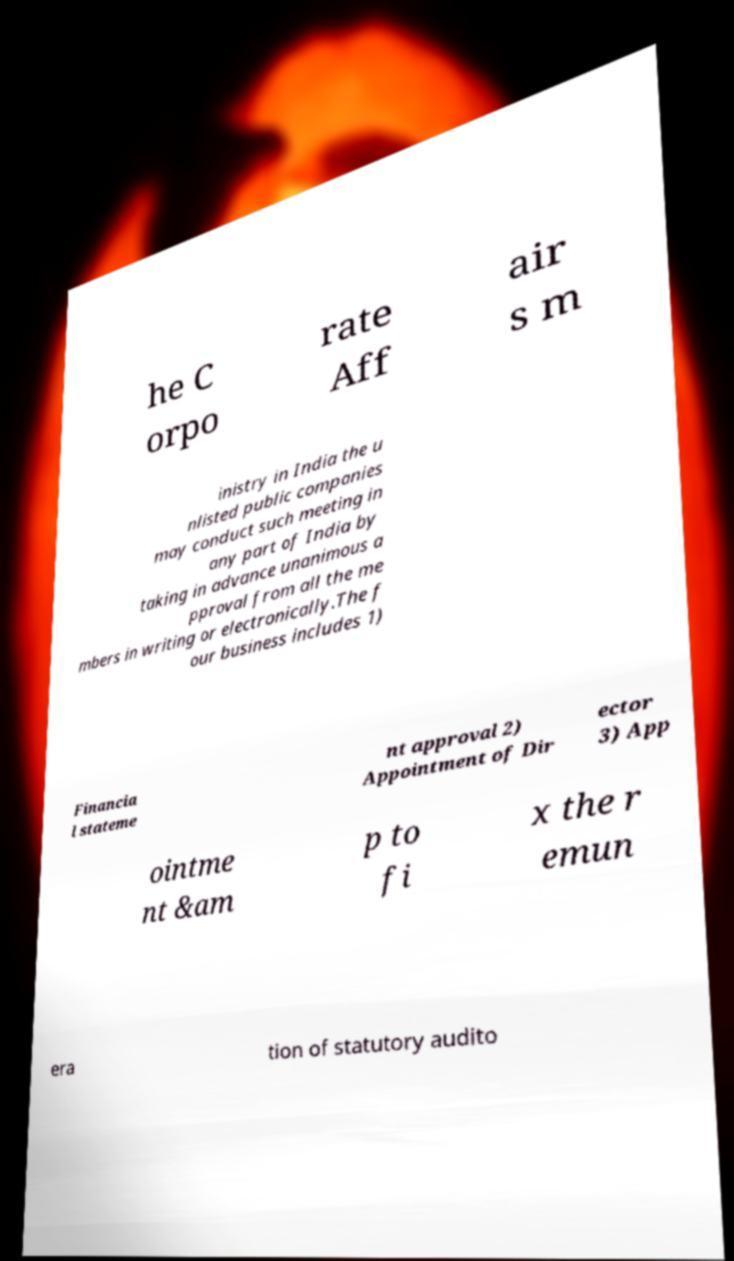Please identify and transcribe the text found in this image. he C orpo rate Aff air s m inistry in India the u nlisted public companies may conduct such meeting in any part of India by taking in advance unanimous a pproval from all the me mbers in writing or electronically.The f our business includes 1) Financia l stateme nt approval 2) Appointment of Dir ector 3) App ointme nt &am p to fi x the r emun era tion of statutory audito 